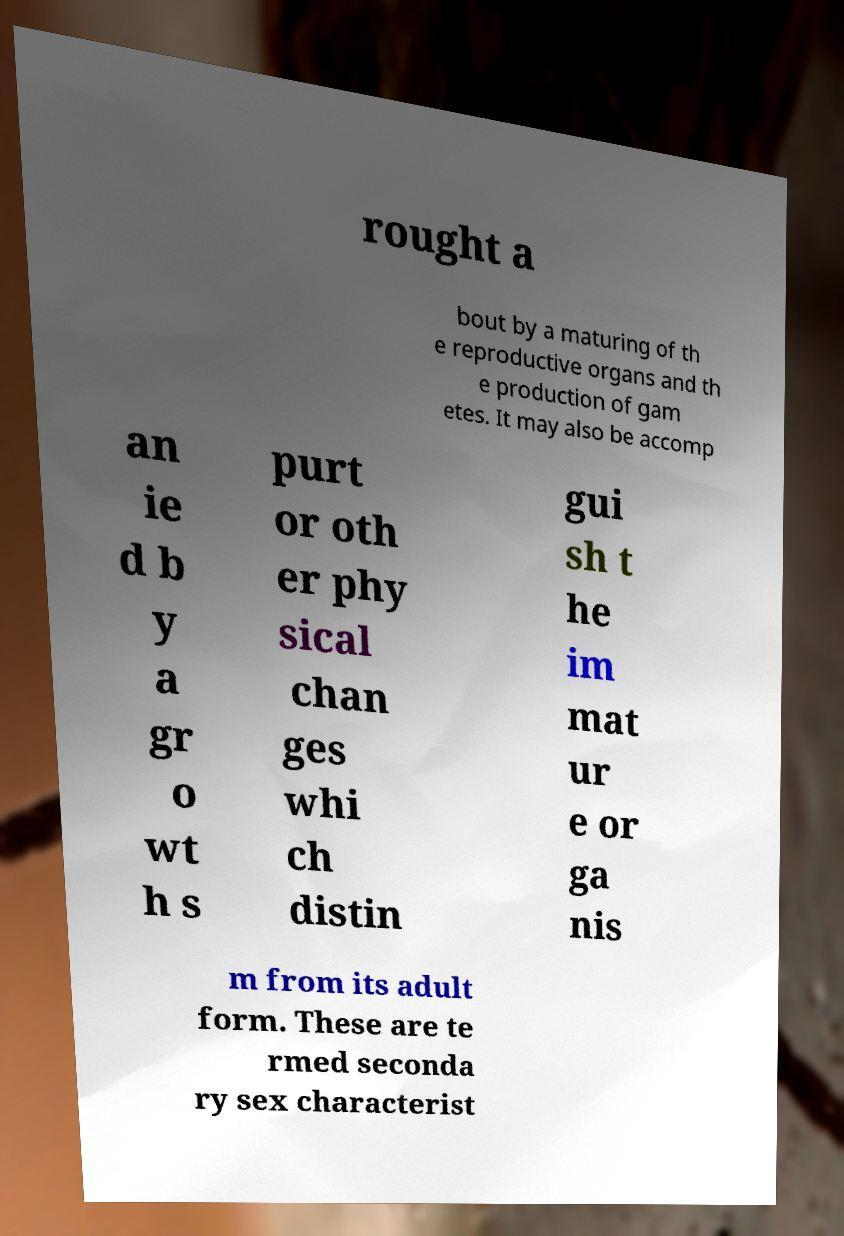There's text embedded in this image that I need extracted. Can you transcribe it verbatim? rought a bout by a maturing of th e reproductive organs and th e production of gam etes. It may also be accomp an ie d b y a gr o wt h s purt or oth er phy sical chan ges whi ch distin gui sh t he im mat ur e or ga nis m from its adult form. These are te rmed seconda ry sex characterist 